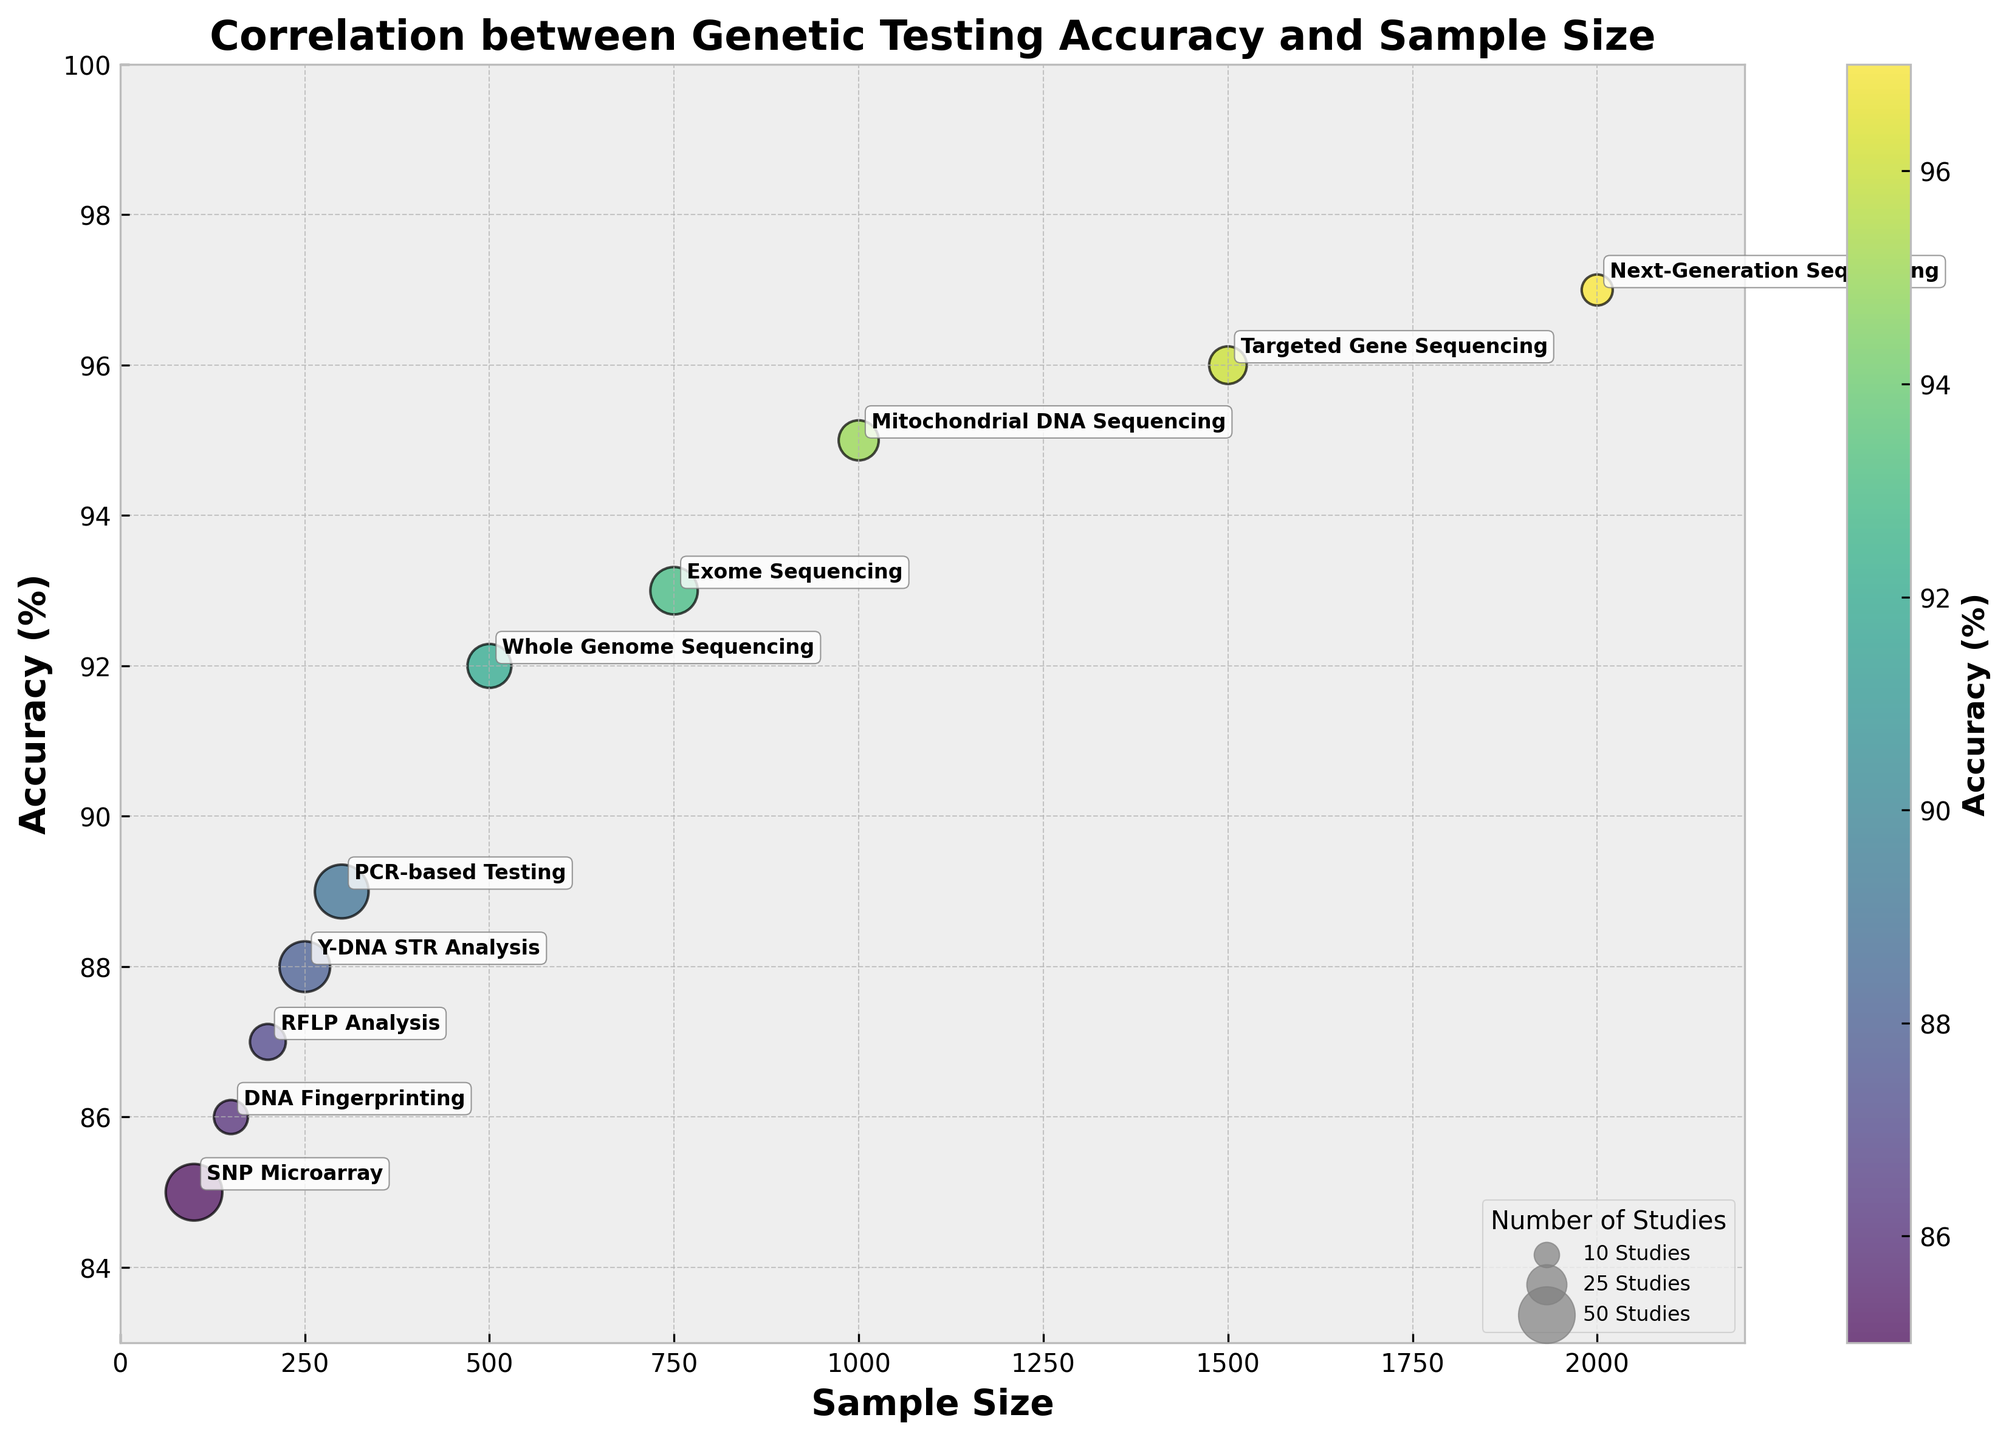What is the title of the plot? The title is displayed at the top of the plot, usually in a larger and bold font, indicating what the plot represents.
Answer: Correlation between Genetic Testing Accuracy and Sample Size What are the labels on the x and y axes? The x and y axes are labeled with descriptions that indicate what each axis represents. These are usually located adjacent to the axes with horizontal and vertical text orientations, respectively.
Answer: Sample Size, Accuracy (%) Which testing method has the highest accuracy, and what is that accuracy? This can be determined by locating the bubble positioned furthest along the y-axis (highest value) and checking the annotated label.
Answer: Next-Generation Sequencing, 97% What is the sample size and accuracy for the PCR-based Testing method? Find the bubble labeled "PCR-based Testing" and look at its position along the x-axis for sample size and y-axis for accuracy.
Answer: 300, 89% How many different genetic testing methods are compared in the plot? Count the number of unique annotations (testing method labels) next to the bubbles in the plot.
Answer: 10 Which testing method is represented by the largest bubble, and how many studies does it correspond to? The size of the bubble corresponds to the number of studies. The largest bubble indicates the method with the highest number of studies. Check the annotation to see the testing method.
Answer: SNP Microarray, 50 studies Compare the accuracies of Whole Genome Sequencing and Exome Sequencing. Which one is more accurate and by how much? Identify the bubbles for Whole Genome Sequencing and Exome Sequencing, check their y-axis positions to see their accuracies, and calculate the difference.
Answer: Exome Sequencing is more accurate by 1% What is the average accuracy of genetic testing methods with a sample size of over 1000? Identify the bubbles representing methods with sample sizes over 1000, sum their accuracies, and divide by the number of those methods. These methods are Next-Generation Sequencing (97%), Mitochondrial DNA Sequencing (95%), and Targeted Gene Sequencing (96%). The average is: (97 + 95 + 96) / 3 = 96%.
Answer: 96% Which testing method has an accuracy of 88%, and how many studies does it correspond to? Find the bubble located at 88% accuracy along the y-axis, check the annotation for the testing method, and read the size of the bubble for the number of studies.
Answer: Y-DNA STR Analysis, 40 studies Between SNP Microarray and RFLP Analysis, which has a larger sample size and by how much? Compare the sample size values along the x-axis for both testing methods and subtract the smaller value from the larger value. SNP Microarray has a sample size of 100, and RFLP Analysis has a sample size of 200, so the difference is 200 - 100 = 100.
Answer: RFLP Analysis has a larger sample size by 100 